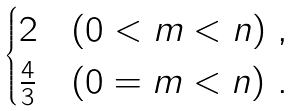<formula> <loc_0><loc_0><loc_500><loc_500>\begin{cases} 2 & ( 0 < m < n ) \ , \\ \frac { 4 } { 3 } & ( 0 = m < n ) \ . \end{cases}</formula> 